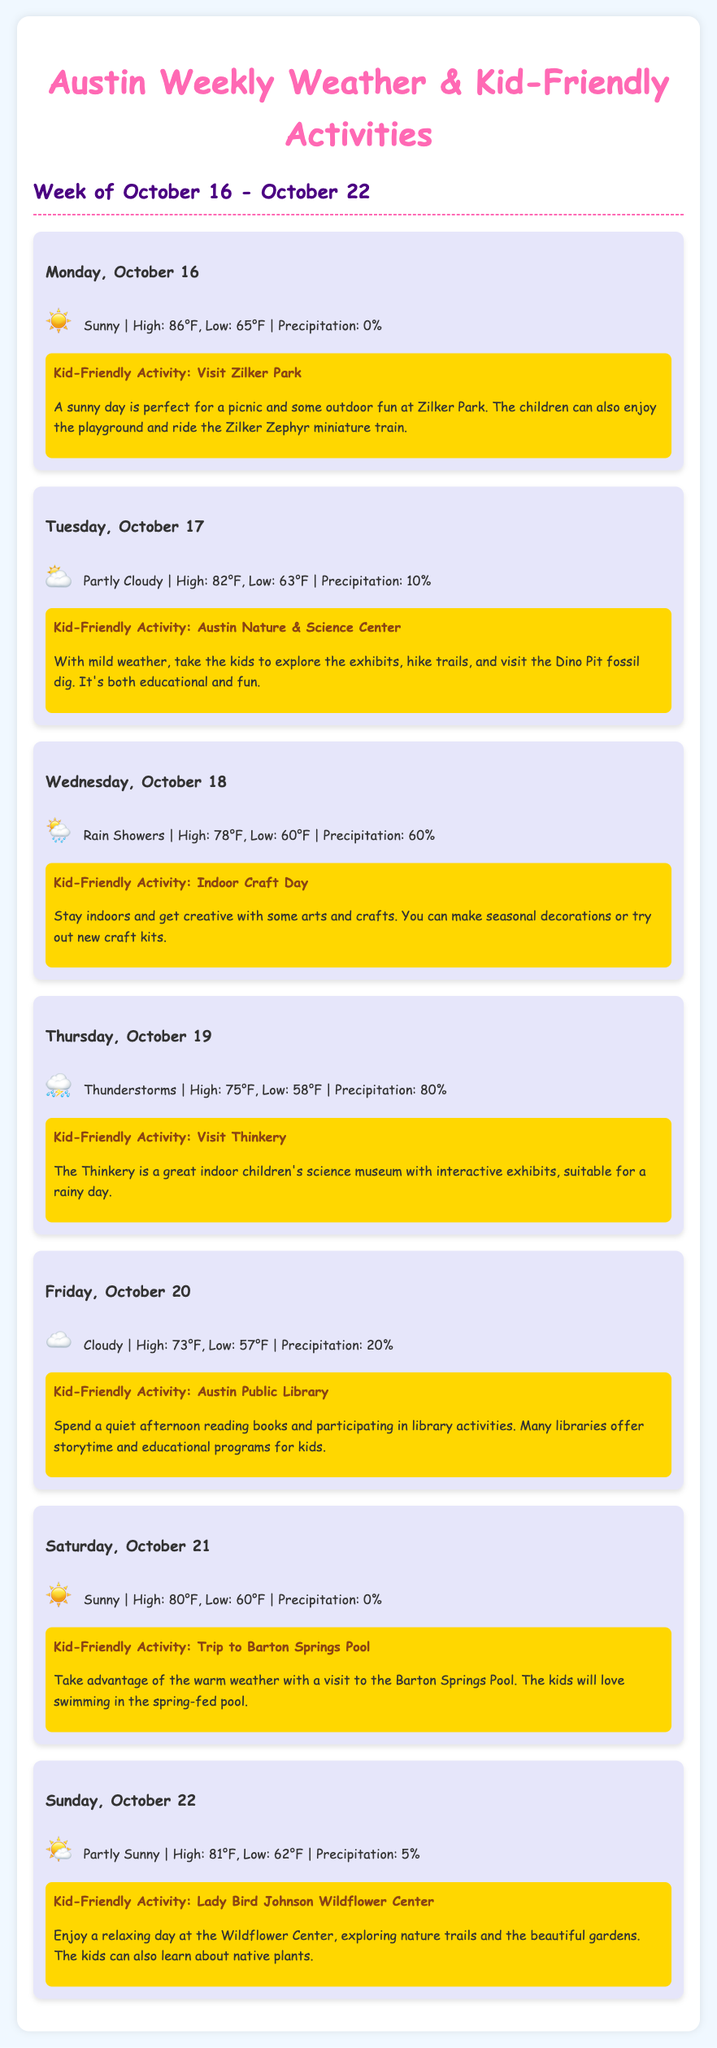What is the high temperature on Monday? The high temperature for Monday, October 16, is stated in the document as 86°F.
Answer: 86°F What activity is suggested for Tuesday? The suggested activity for Tuesday, October 17, is provided, which is visiting the Austin Nature & Science Center.
Answer: Austin Nature & Science Center What is the precipitation percentage for Wednesday? The document lists the precipitation percentage for Wednesday, October 18, as 60%.
Answer: 60% Which day has thunderstorms? The document indicates that Thursday, October 19, has thunderstorms in the weather forecast.
Answer: Thursday, October 19 How many kid-friendly activities are listed in the document? The document mentions a total of seven days, each with a corresponding activity, accumulating to seven activities.
Answer: Seven What type of weather can we expect on Saturday? The document describes the weather for Saturday, October 21, as sunny.
Answer: Sunny What indoor activity is suggested for Thursday? The indoor activity for Thursday, October 19, is visiting Thinkery, an indoor children's science museum.
Answer: Visit Thinkery Which outdoor location is recommended for a sunny day? The document recommends visiting Zilker Park as an outdoor location for a sunny day on Monday.
Answer: Zilker Park 